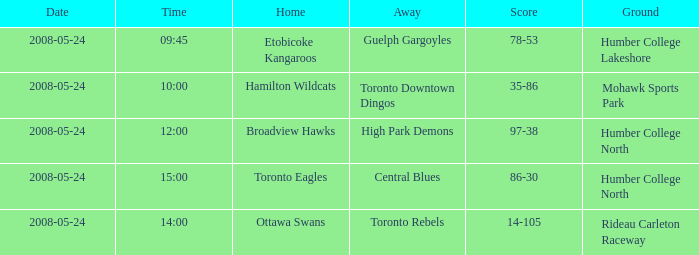On what day was the game that ended in a score of 97-38? 2008-05-24. 